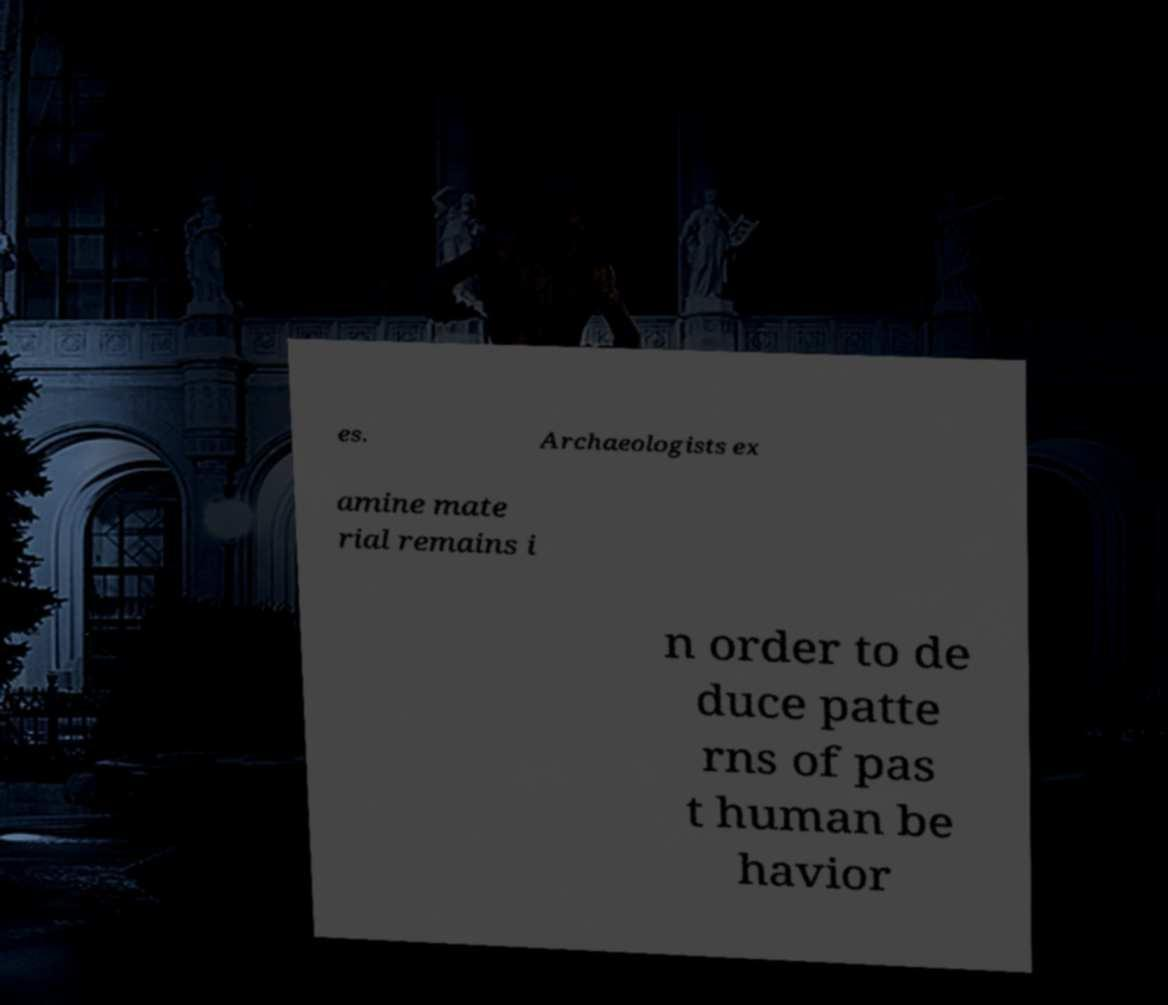Could you assist in decoding the text presented in this image and type it out clearly? es. Archaeologists ex amine mate rial remains i n order to de duce patte rns of pas t human be havior 